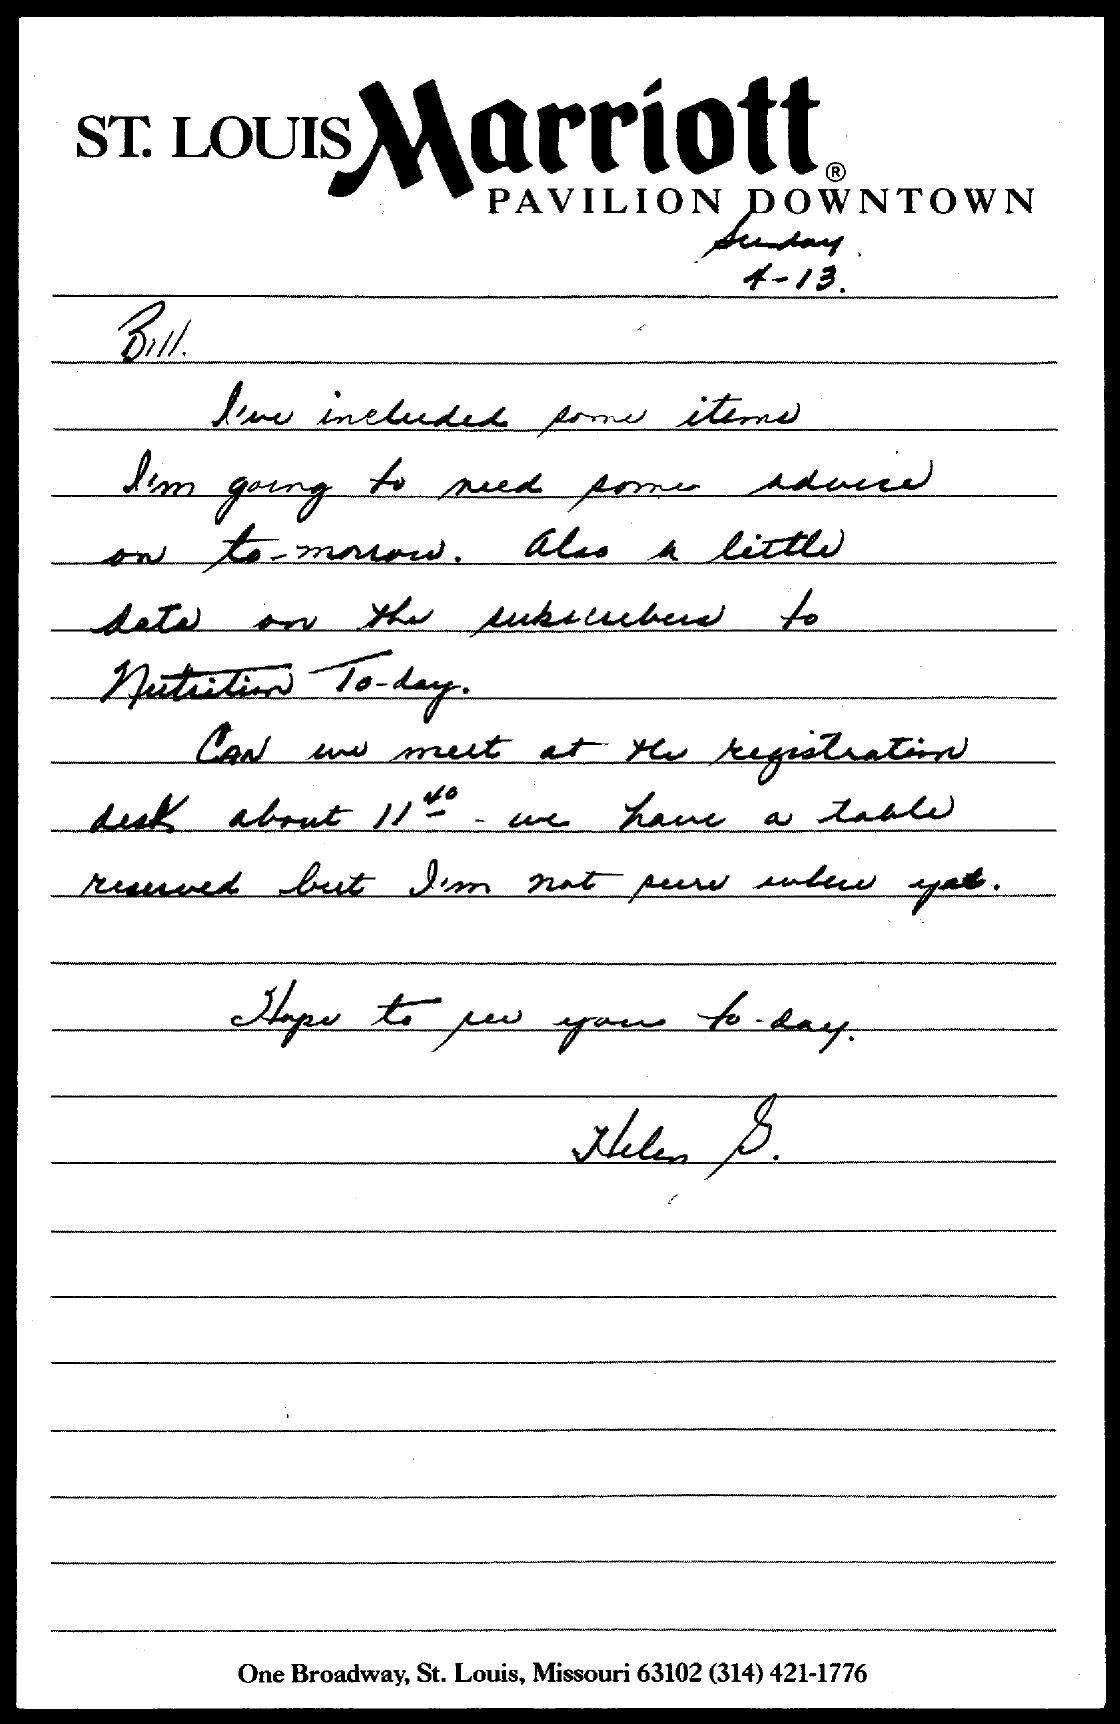What is the date mentioned in the given page ?
Keep it short and to the point. 4-13. 